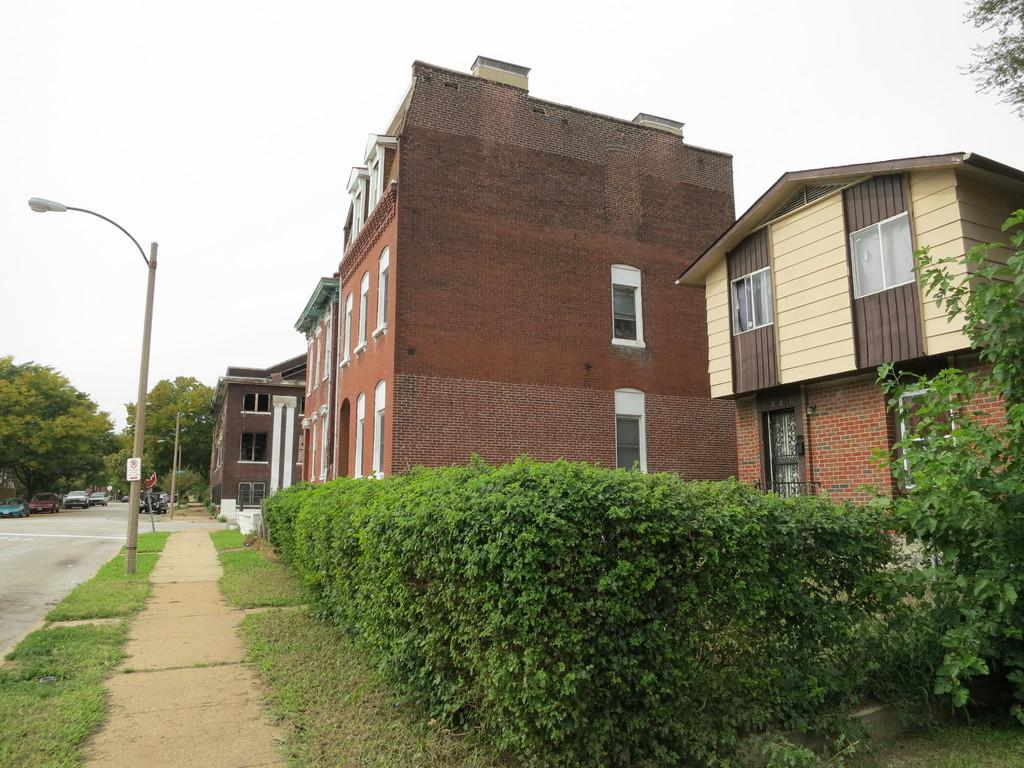What type of structures can be seen in the image? There are buildings in the image. What type of vegetation is present in the image? There are bushes and trees in the image. What type of surface is visible in the image? There is a path and green grass in the image. What type of man-made object is present in the image? There is a light pole in the image. What can be seen in the background of the image? There are trees, cars, and a clear sky in the background of the image. Can you see any wrens flying over the coast in the image? There is no coast or wrens present in the image. Is there any steam coming out of the buildings in the image? There is no steam visible in the image. 